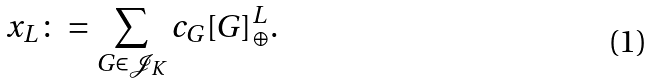<formula> <loc_0><loc_0><loc_500><loc_500>x _ { L } \colon = \sum _ { G \in \mathcal { J } _ { K } } c _ { G } [ G ] _ { \oplus } ^ { L } .</formula> 